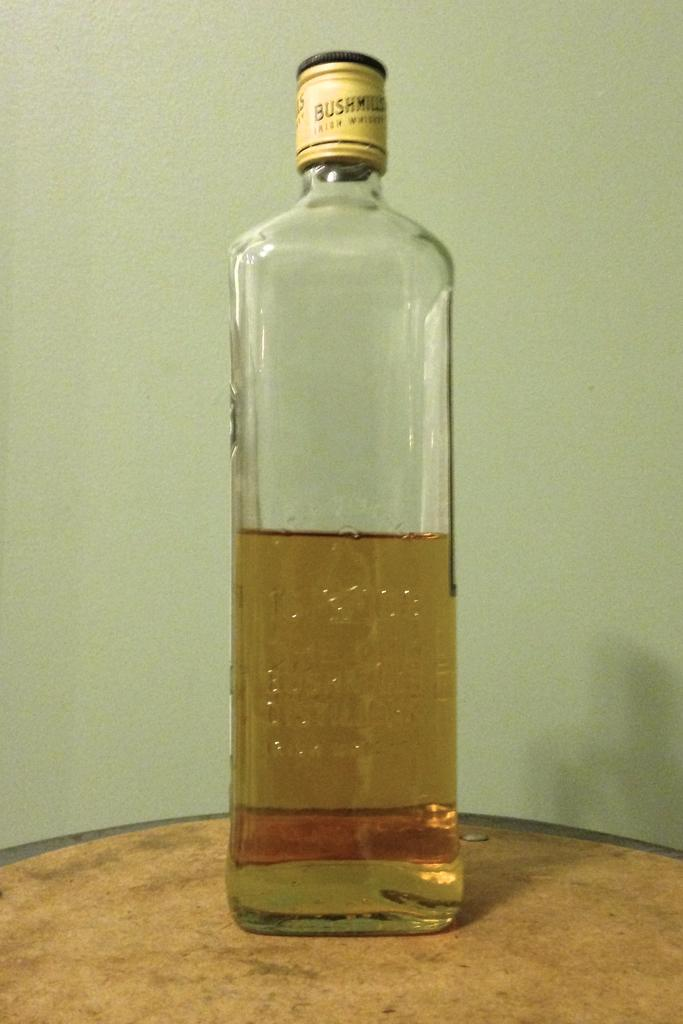What is inside the bottle that is visible in the image? There is a drink in the bottle. Where is the bottle located in the image? The bottle is placed on a table. What can be seen in the background of the image? There is a wall in the background of the image. What type of flesh can be seen on the wall in the image? There is no flesh present on the wall in the image; it is a solid structure. 